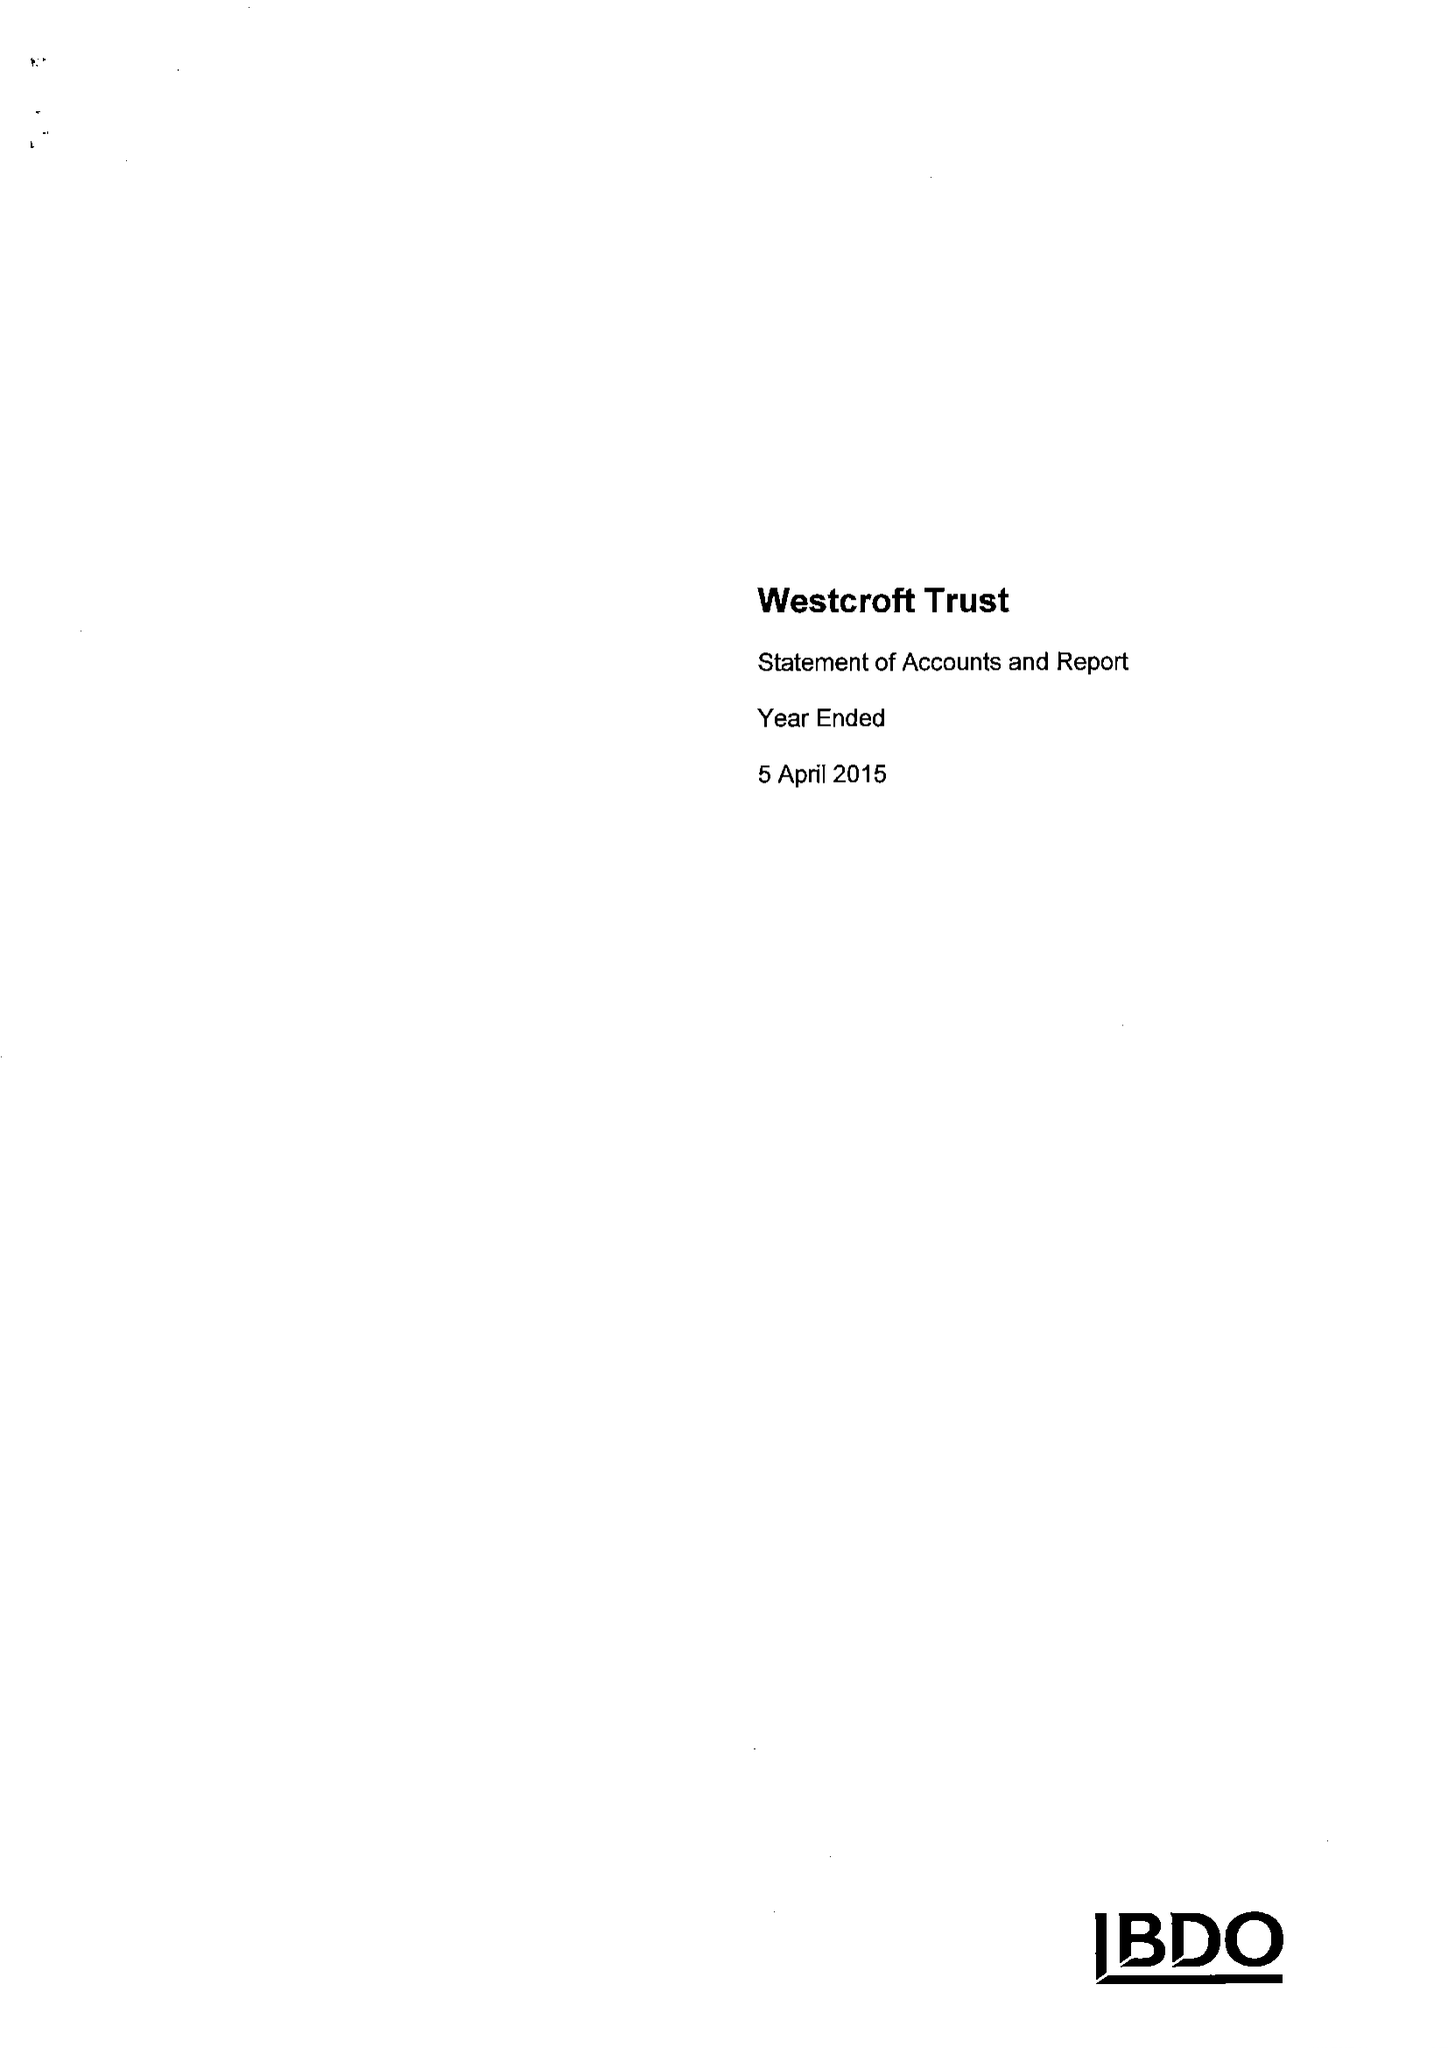What is the value for the charity_name?
Answer the question using a single word or phrase. The Westcroft Trust 